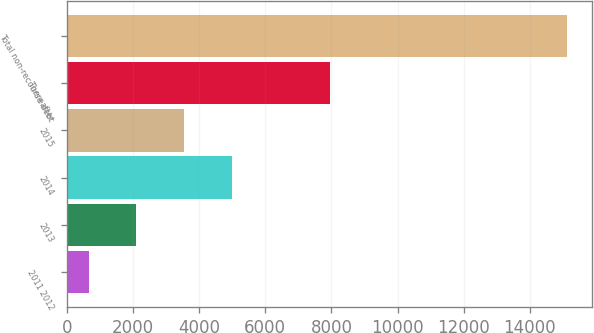Convert chart to OTSL. <chart><loc_0><loc_0><loc_500><loc_500><bar_chart><fcel>2011 2012<fcel>2013<fcel>2014<fcel>2015<fcel>Thereafter<fcel>Total non-recourse debt<nl><fcel>657<fcel>2103.4<fcel>4996.2<fcel>3549.8<fcel>7957<fcel>15121<nl></chart> 